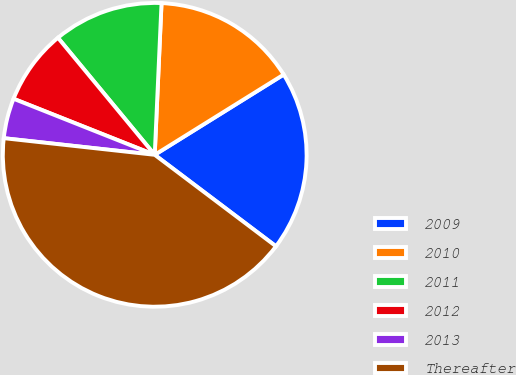<chart> <loc_0><loc_0><loc_500><loc_500><pie_chart><fcel>2009<fcel>2010<fcel>2011<fcel>2012<fcel>2013<fcel>Thereafter<nl><fcel>19.15%<fcel>15.43%<fcel>11.71%<fcel>7.99%<fcel>4.27%<fcel>41.47%<nl></chart> 